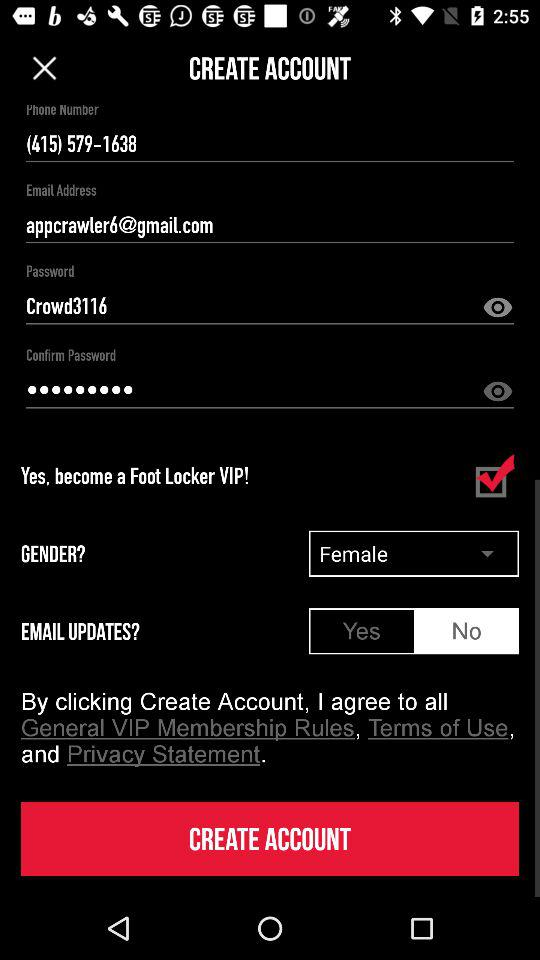What is the phone number shown on the screen? The phone number shown on the screen is (415) 579-1638. 